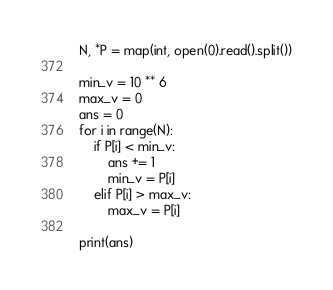Convert code to text. <code><loc_0><loc_0><loc_500><loc_500><_Python_>N, *P = map(int, open(0).read().split())

min_v = 10 ** 6
max_v = 0
ans = 0
for i in range(N):
    if P[i] < min_v:
        ans += 1
        min_v = P[i]
    elif P[i] > max_v:
        max_v = P[i]
        
print(ans)
</code> 